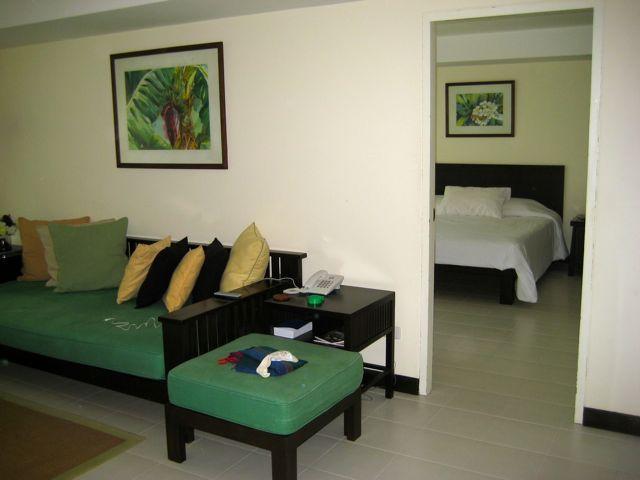How many cushions does the couch in the picture have?
Give a very brief answer. 8. 